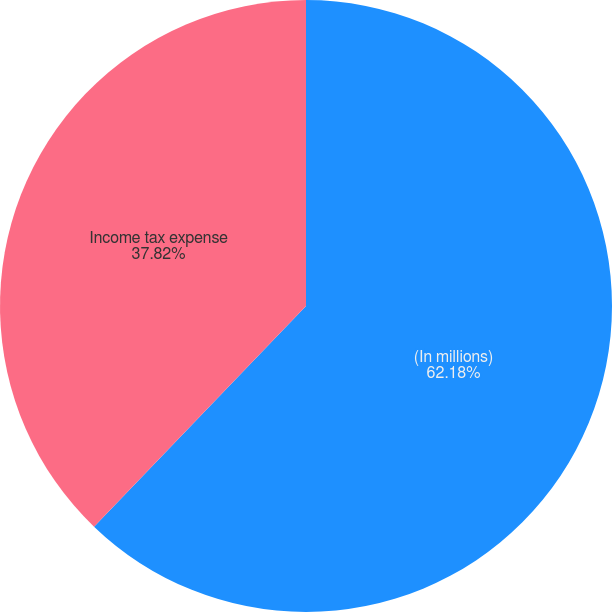Convert chart to OTSL. <chart><loc_0><loc_0><loc_500><loc_500><pie_chart><fcel>(In millions)<fcel>Income tax expense<nl><fcel>62.18%<fcel>37.82%<nl></chart> 